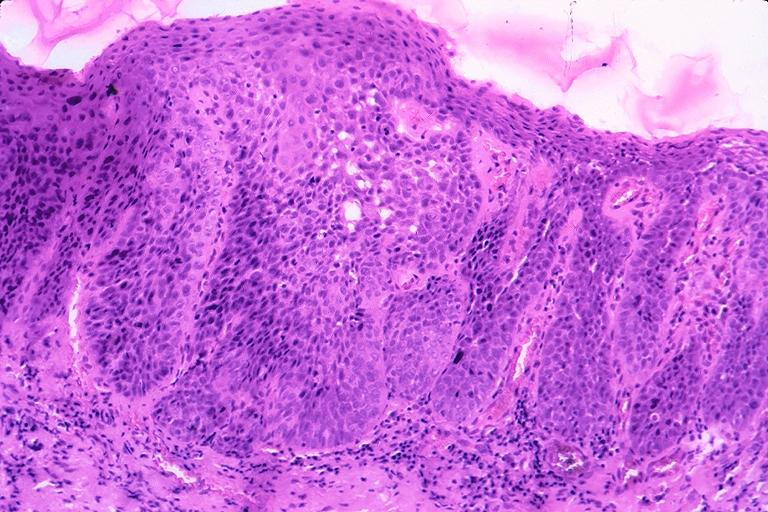does this image show squamous cell carcinoma?
Answer the question using a single word or phrase. Yes 